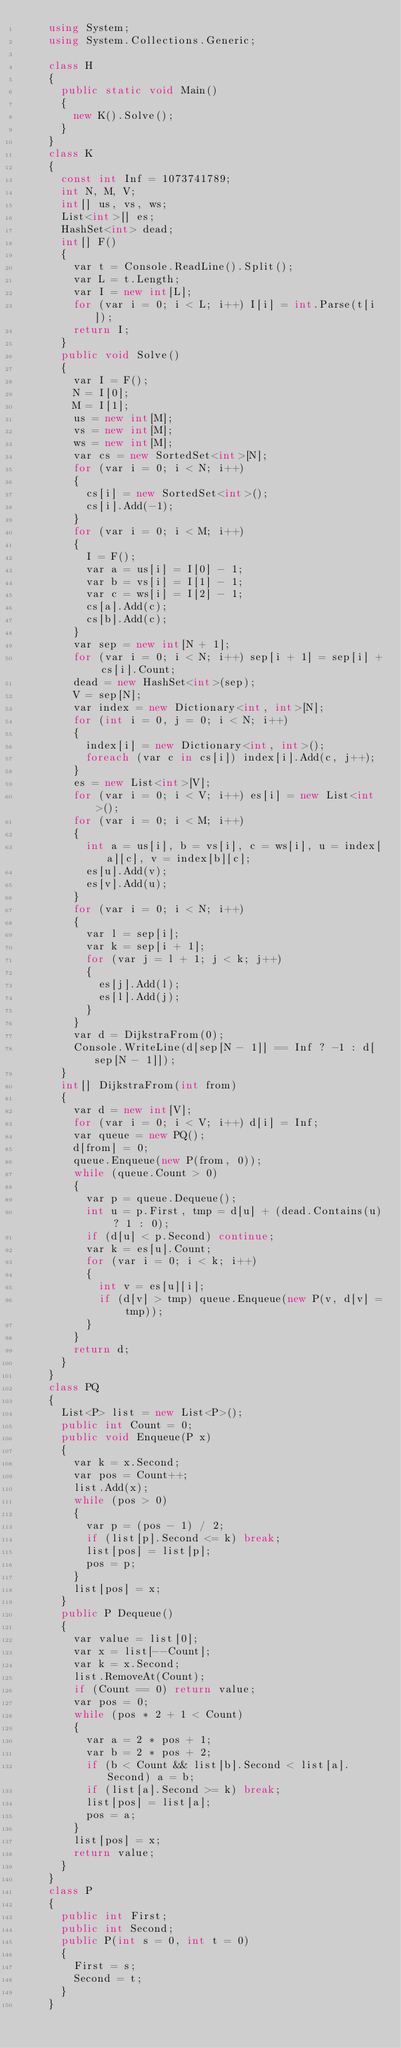<code> <loc_0><loc_0><loc_500><loc_500><_C#_>    using System;
    using System.Collections.Generic;
     
    class H
    {
    	public static void Main()
    	{
    		new K().Solve();
    	}
    }
    class K
    {
    	const int Inf = 1073741789;
    	int N, M, V;
    	int[] us, vs, ws;
    	List<int>[] es;
    	HashSet<int> dead;
    	int[] F()
    	{
    		var t = Console.ReadLine().Split();
    		var L = t.Length;
    		var I = new int[L];
    		for (var i = 0; i < L; i++) I[i] = int.Parse(t[i]);
    		return I;
    	}
    	public void Solve()
    	{
    		var I = F();
    		N = I[0];
    		M = I[1];
    		us = new int[M];
    		vs = new int[M];
    		ws = new int[M];
    		var cs = new SortedSet<int>[N];
    		for (var i = 0; i < N; i++)
    		{
    			cs[i] = new SortedSet<int>();
    			cs[i].Add(-1);
    		}
    		for (var i = 0; i < M; i++)
    		{
    			I = F();
    			var a = us[i] = I[0] - 1;
    			var b = vs[i] = I[1] - 1;
    			var c = ws[i] = I[2] - 1;
    			cs[a].Add(c);
    			cs[b].Add(c);
    		}
    		var sep = new int[N + 1];
    		for (var i = 0; i < N; i++) sep[i + 1] = sep[i] + cs[i].Count;
    		dead = new HashSet<int>(sep);
    		V = sep[N];
    		var index = new Dictionary<int, int>[N];
    		for (int i = 0, j = 0; i < N; i++)
    		{
    			index[i] = new Dictionary<int, int>();
    			foreach (var c in cs[i]) index[i].Add(c, j++);
    		}
    		es = new List<int>[V];
    		for (var i = 0; i < V; i++) es[i] = new List<int>();
    		for (var i = 0; i < M; i++)
    		{
    			int a = us[i], b = vs[i], c = ws[i], u = index[a][c], v = index[b][c];
    			es[u].Add(v);
    			es[v].Add(u);
    		}
    		for (var i = 0; i < N; i++)
    		{
    			var l = sep[i];
    			var k = sep[i + 1];
    			for (var j = l + 1; j < k; j++)
    			{
    				es[j].Add(l);
    				es[l].Add(j);
    			}
    		}
    		var d = DijkstraFrom(0);
    		Console.WriteLine(d[sep[N - 1]] == Inf ? -1 : d[sep[N - 1]]);
    	}
    	int[] DijkstraFrom(int from)
    	{
    		var d = new int[V];
    		for (var i = 0; i < V; i++) d[i] = Inf;
    		var queue = new PQ();
    		d[from] = 0;
    		queue.Enqueue(new P(from, 0));
    		while (queue.Count > 0)
    		{
    			var p = queue.Dequeue();
    			int u = p.First, tmp = d[u] + (dead.Contains(u) ? 1 : 0);
    			if (d[u] < p.Second) continue;
    			var k = es[u].Count;
    			for (var i = 0; i < k; i++)
    			{
    				int v = es[u][i];
    				if (d[v] > tmp) queue.Enqueue(new P(v, d[v] = tmp));
    			}
    		}
    		return d;
    	}
    }
    class PQ
    {
    	List<P> list = new List<P>();
    	public int Count = 0;
    	public void Enqueue(P x)
    	{
    		var k = x.Second;
    		var pos = Count++;
    		list.Add(x);
    		while (pos > 0)
    		{
    			var p = (pos - 1) / 2;
    			if (list[p].Second <= k) break;
    			list[pos] = list[p];
    			pos = p;
    		}
    		list[pos] = x;
    	}
    	public P Dequeue()
    	{
    		var value = list[0];
    		var x = list[--Count];
    		var k = x.Second;
    		list.RemoveAt(Count);
    		if (Count == 0) return value;
    		var pos = 0;
    		while (pos * 2 + 1 < Count)
    		{
    			var a = 2 * pos + 1;
    			var b = 2 * pos + 2;
    			if (b < Count && list[b].Second < list[a].Second) a = b;
    			if (list[a].Second >= k) break;
    			list[pos] = list[a];
    			pos = a;
    		}
    		list[pos] = x;
    		return value;
    	}
    }
    class P
    {
    	public int First;
    	public int Second;
    	public P(int s = 0, int t = 0)
    	{
    		First = s;
    		Second = t;
    	}
    }

</code> 